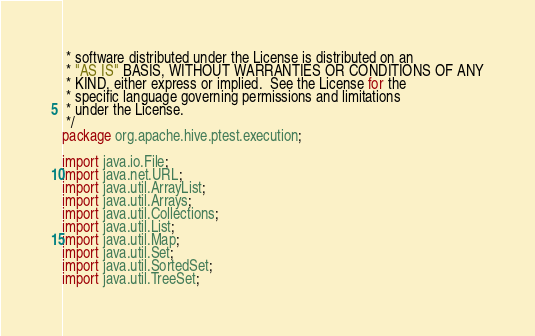Convert code to text. <code><loc_0><loc_0><loc_500><loc_500><_Java_> * software distributed under the License is distributed on an
 * "AS IS" BASIS, WITHOUT WARRANTIES OR CONDITIONS OF ANY
 * KIND, either express or implied.  See the License for the
 * specific language governing permissions and limitations
 * under the License.
 */
package org.apache.hive.ptest.execution;

import java.io.File;
import java.net.URL;
import java.util.ArrayList;
import java.util.Arrays;
import java.util.Collections;
import java.util.List;
import java.util.Map;
import java.util.Set;
import java.util.SortedSet;
import java.util.TreeSet;</code> 